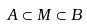Convert formula to latex. <formula><loc_0><loc_0><loc_500><loc_500>A \subset M \subset B</formula> 